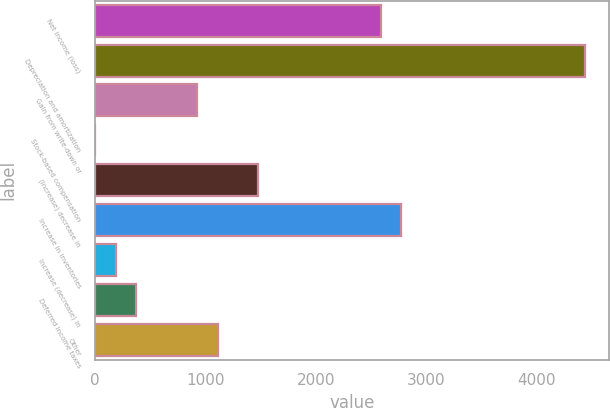<chart> <loc_0><loc_0><loc_500><loc_500><bar_chart><fcel>Net income (loss)<fcel>Depreciation and amortization<fcel>Gain from write-down or<fcel>Stock-based compensation<fcel>(Increase) decrease in<fcel>Increase in inventories<fcel>Increase (decrease) in<fcel>Deferred income taxes<fcel>Other<nl><fcel>2587.8<fcel>4434.8<fcel>925.5<fcel>2<fcel>1479.6<fcel>2772.5<fcel>186.7<fcel>371.4<fcel>1110.2<nl></chart> 